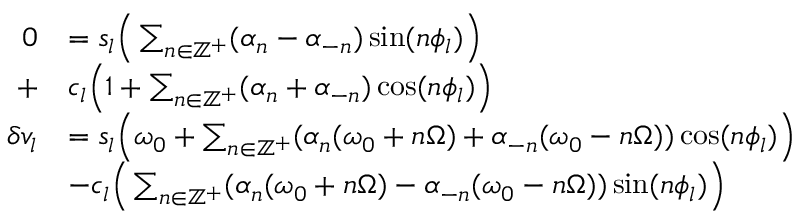Convert formula to latex. <formula><loc_0><loc_0><loc_500><loc_500>\begin{array} { r l } { 0 } & { = s _ { l } \left ( \sum _ { n \in \mathbb { Z } ^ { + } } ( \alpha _ { n } - \alpha _ { - n } ) \sin ( n \phi _ { l } ) \right ) } \\ { + } & { c _ { l } \left ( 1 + \sum _ { n \in \mathbb { Z } ^ { + } } ( \alpha _ { n } + \alpha _ { - n } ) \cos ( n \phi _ { l } ) \right ) } \\ { \delta v _ { l } } & { = s _ { l } \left ( \omega _ { 0 } + \sum _ { n \in \mathbb { Z } ^ { + } } ( \alpha _ { n } ( \omega _ { 0 } + n \Omega ) + \alpha _ { - n } ( \omega _ { 0 } - n \Omega ) ) \cos ( n \phi _ { l } ) \right ) } \\ & { - c _ { l } \left ( \sum _ { n \in \mathbb { Z } ^ { + } } ( \alpha _ { n } ( \omega _ { 0 } + n \Omega ) - \alpha _ { - n } ( \omega _ { 0 } - n \Omega ) ) \sin ( n \phi _ { l } ) \right ) } \end{array}</formula> 